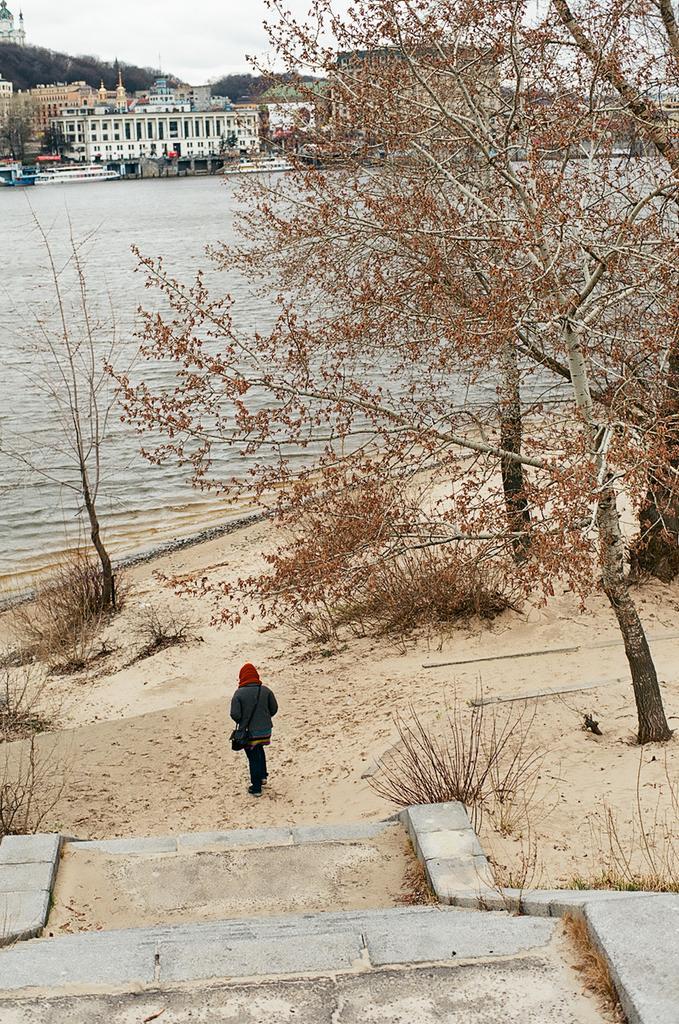Could you give a brief overview of what you see in this image? There is a person in black color dress, wearing black color handbag and walking on the sand surface of a ground near steps. On the right side, there is a tree. In the background, there are trees and plants on the sand surface of a ground, there is a water of a river, there are boats parked aside on the water of the river, there is a building and trees on the hill and there is sky. 